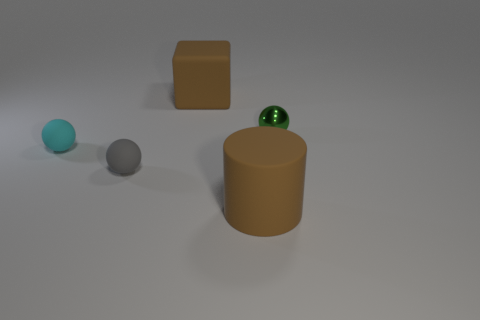Is there any other thing that is made of the same material as the tiny green thing?
Give a very brief answer. No. There is a cyan matte thing; how many big things are in front of it?
Provide a short and direct response. 1. What number of tiny things are there?
Offer a very short reply. 3. Does the green metal ball have the same size as the brown matte cylinder?
Your answer should be compact. No. Are there any gray matte objects that are to the right of the gray object right of the matte ball to the left of the tiny gray rubber object?
Make the answer very short. No. What material is the cyan thing that is the same shape as the tiny gray object?
Your answer should be very brief. Rubber. What is the color of the small ball that is right of the large brown cube?
Provide a short and direct response. Green. The block is what size?
Your response must be concise. Large. Does the green ball have the same size as the ball that is in front of the cyan ball?
Your response must be concise. Yes. What color is the big rubber thing that is to the left of the big brown thing in front of the tiny object that is right of the big brown matte cylinder?
Offer a very short reply. Brown. 